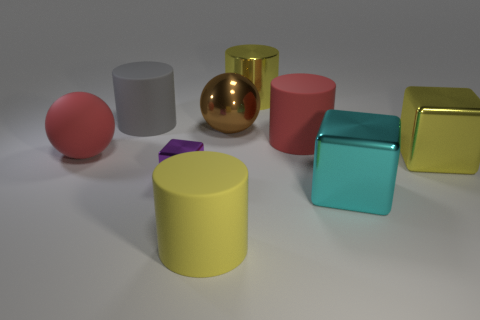Add 1 yellow metallic things. How many objects exist? 10 Subtract all blocks. How many objects are left? 6 Add 4 large yellow matte things. How many large yellow matte things are left? 5 Add 5 yellow metal blocks. How many yellow metal blocks exist? 6 Subtract 0 yellow balls. How many objects are left? 9 Subtract all big cyan shiny cubes. Subtract all large yellow balls. How many objects are left? 8 